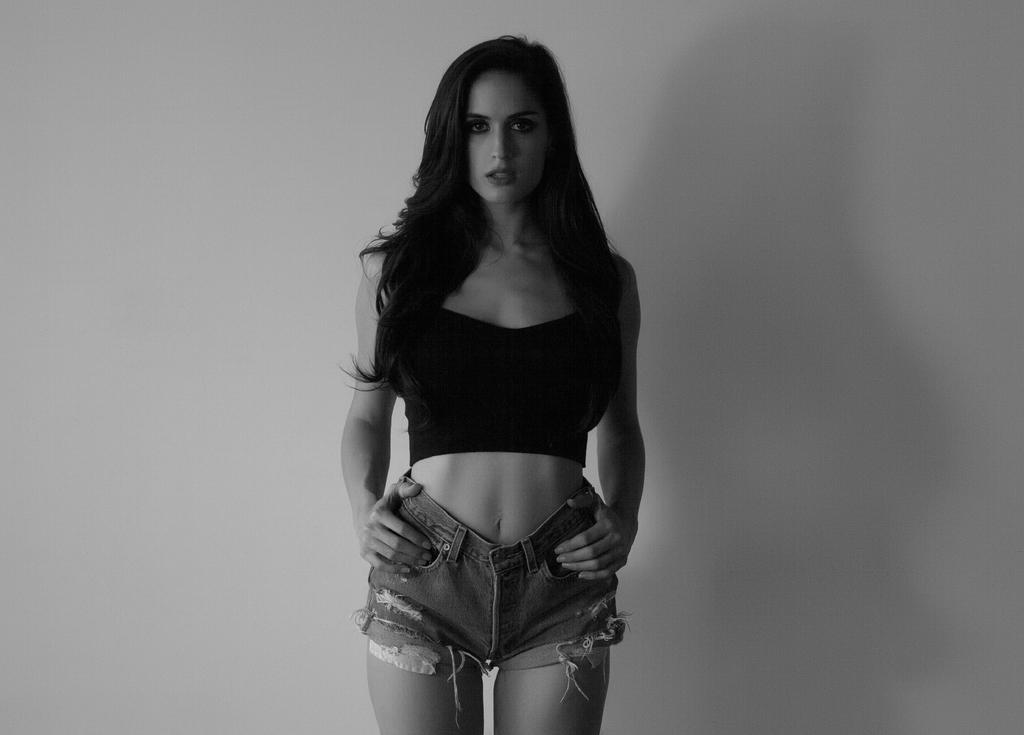Please provide a concise description of this image. This picture seems to be clicked inside. In the center there is a woman wearing black color t-shirt and shorts and standing on the ground. In the background there is a wall. 